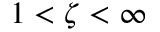Convert formula to latex. <formula><loc_0><loc_0><loc_500><loc_500>1 < \zeta < \infty</formula> 